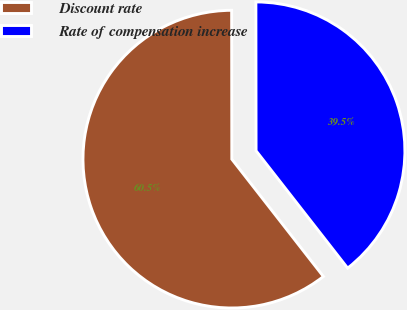<chart> <loc_0><loc_0><loc_500><loc_500><pie_chart><fcel>Discount rate<fcel>Rate of compensation increase<nl><fcel>60.53%<fcel>39.47%<nl></chart> 